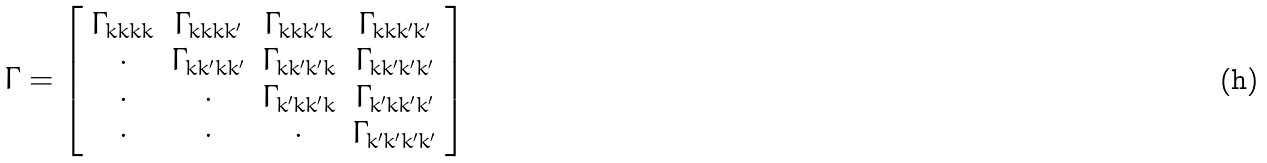Convert formula to latex. <formula><loc_0><loc_0><loc_500><loc_500>\Gamma = \left [ \begin{array} { c c c c } \Gamma _ { k k k k } & \Gamma _ { k k k k ^ { \prime } } & \Gamma _ { k k k ^ { \prime } k } & \Gamma _ { k k k ^ { \prime } k ^ { \prime } } \\ \cdot & \Gamma _ { k k ^ { \prime } k k ^ { \prime } } & \Gamma _ { k k ^ { \prime } k ^ { \prime } k } & \Gamma _ { k k ^ { \prime } k ^ { \prime } k ^ { \prime } } \\ \cdot & \cdot & \Gamma _ { k ^ { \prime } k k ^ { \prime } k } & \Gamma _ { k ^ { \prime } k k ^ { \prime } k ^ { \prime } } \\ \cdot & \cdot & \cdot & \Gamma _ { k ^ { \prime } k ^ { \prime } k ^ { \prime } k ^ { \prime } } \\ \end{array} \right ]</formula> 